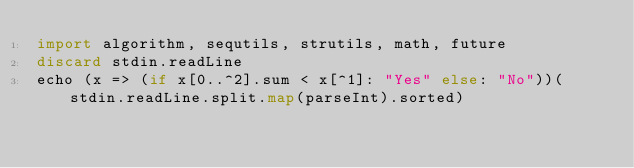<code> <loc_0><loc_0><loc_500><loc_500><_Nim_>import algorithm, sequtils, strutils, math, future
discard stdin.readLine
echo (x => (if x[0..^2].sum < x[^1]: "Yes" else: "No"))(stdin.readLine.split.map(parseInt).sorted)</code> 